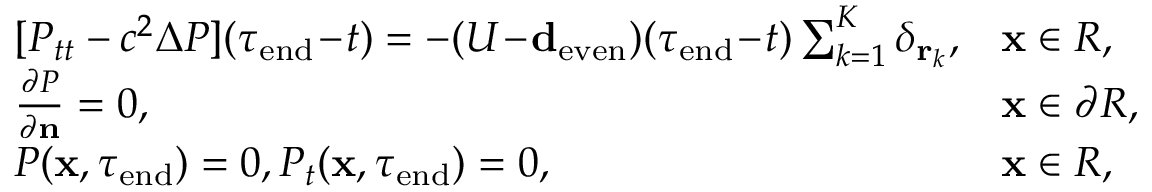Convert formula to latex. <formula><loc_0><loc_0><loc_500><loc_500>\begin{array} { r } { \begin{array} { l l } { [ P _ { t t } - c ^ { 2 } \Delta P ] ( \tau _ { e n d } \, - \, t ) = - ( U \, - \, { \mathbf d _ { e v e n } } ) ( \tau _ { e n d } \, - \, t ) \sum _ { k = 1 } ^ { K } \delta _ { \mathbf r _ { k } } , } & { \mathbf x \in R , } \\ { { \frac { \partial P } { \partial \mathbf n } } = 0 , } & { \mathbf x \in \partial R , } \\ { P ( \mathbf x , \tau _ { e n d } ) = 0 , P _ { t } ( \mathbf x , \tau _ { e n d } ) = 0 , } & { \mathbf x \in R , } \end{array} } \end{array}</formula> 